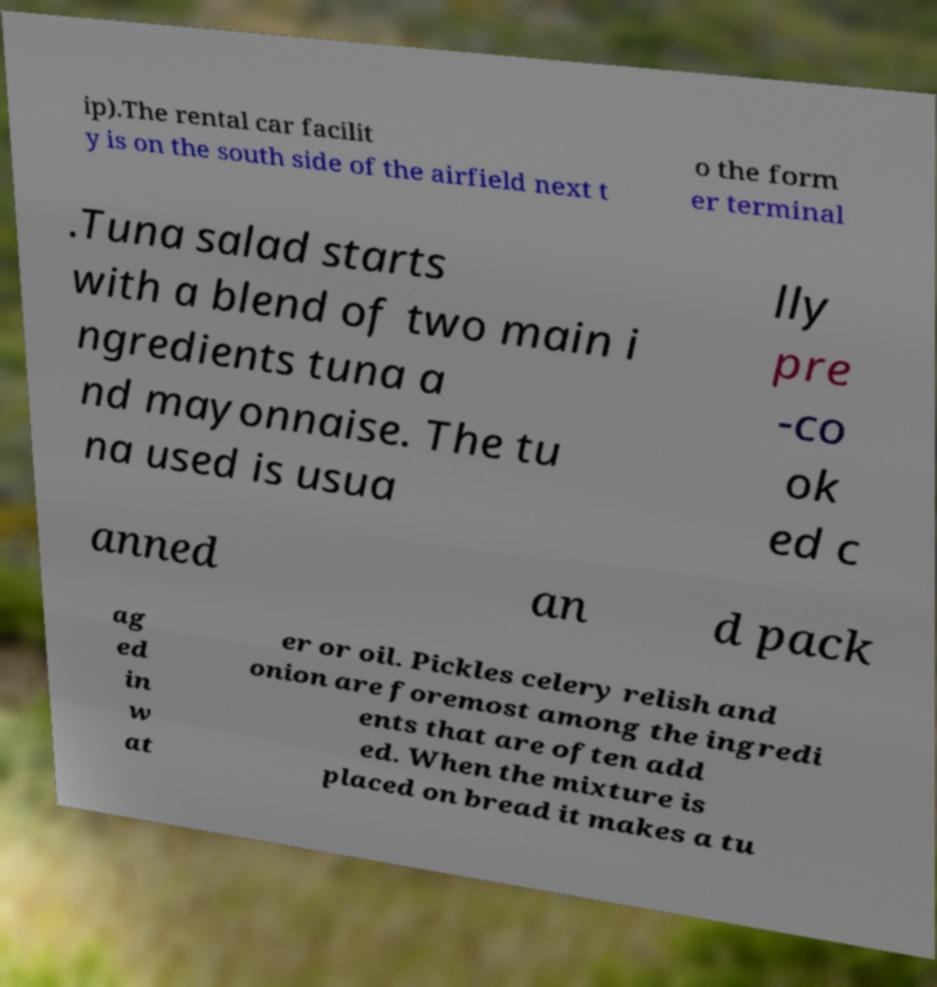I need the written content from this picture converted into text. Can you do that? ip).The rental car facilit y is on the south side of the airfield next t o the form er terminal .Tuna salad starts with a blend of two main i ngredients tuna a nd mayonnaise. The tu na used is usua lly pre -co ok ed c anned an d pack ag ed in w at er or oil. Pickles celery relish and onion are foremost among the ingredi ents that are often add ed. When the mixture is placed on bread it makes a tu 